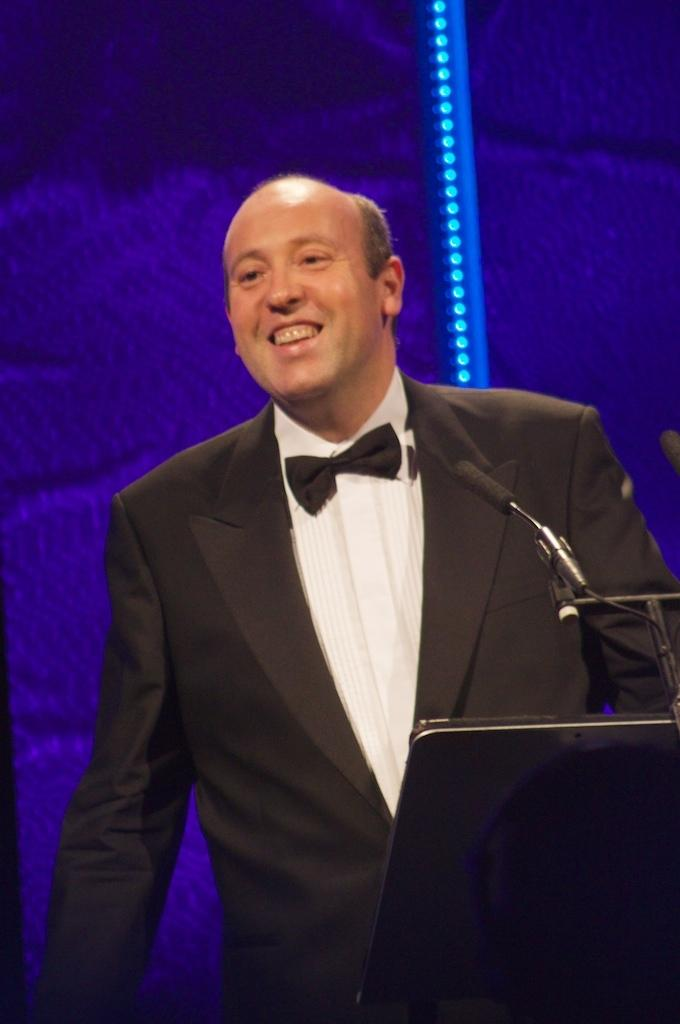Who or what is the main subject in the image? There is a person in the image. What color is the background of the image? The background of the image is blue. What object can be seen on the right side of the image? There is a mic on the right side of the image. Where are the lights located in the image? There are lights in the top right of the image. What type of border is present around the person in the image? There is no border present around the person in the image. What decision is the person making in the image? The image does not provide any information about a decision being made by the person. 